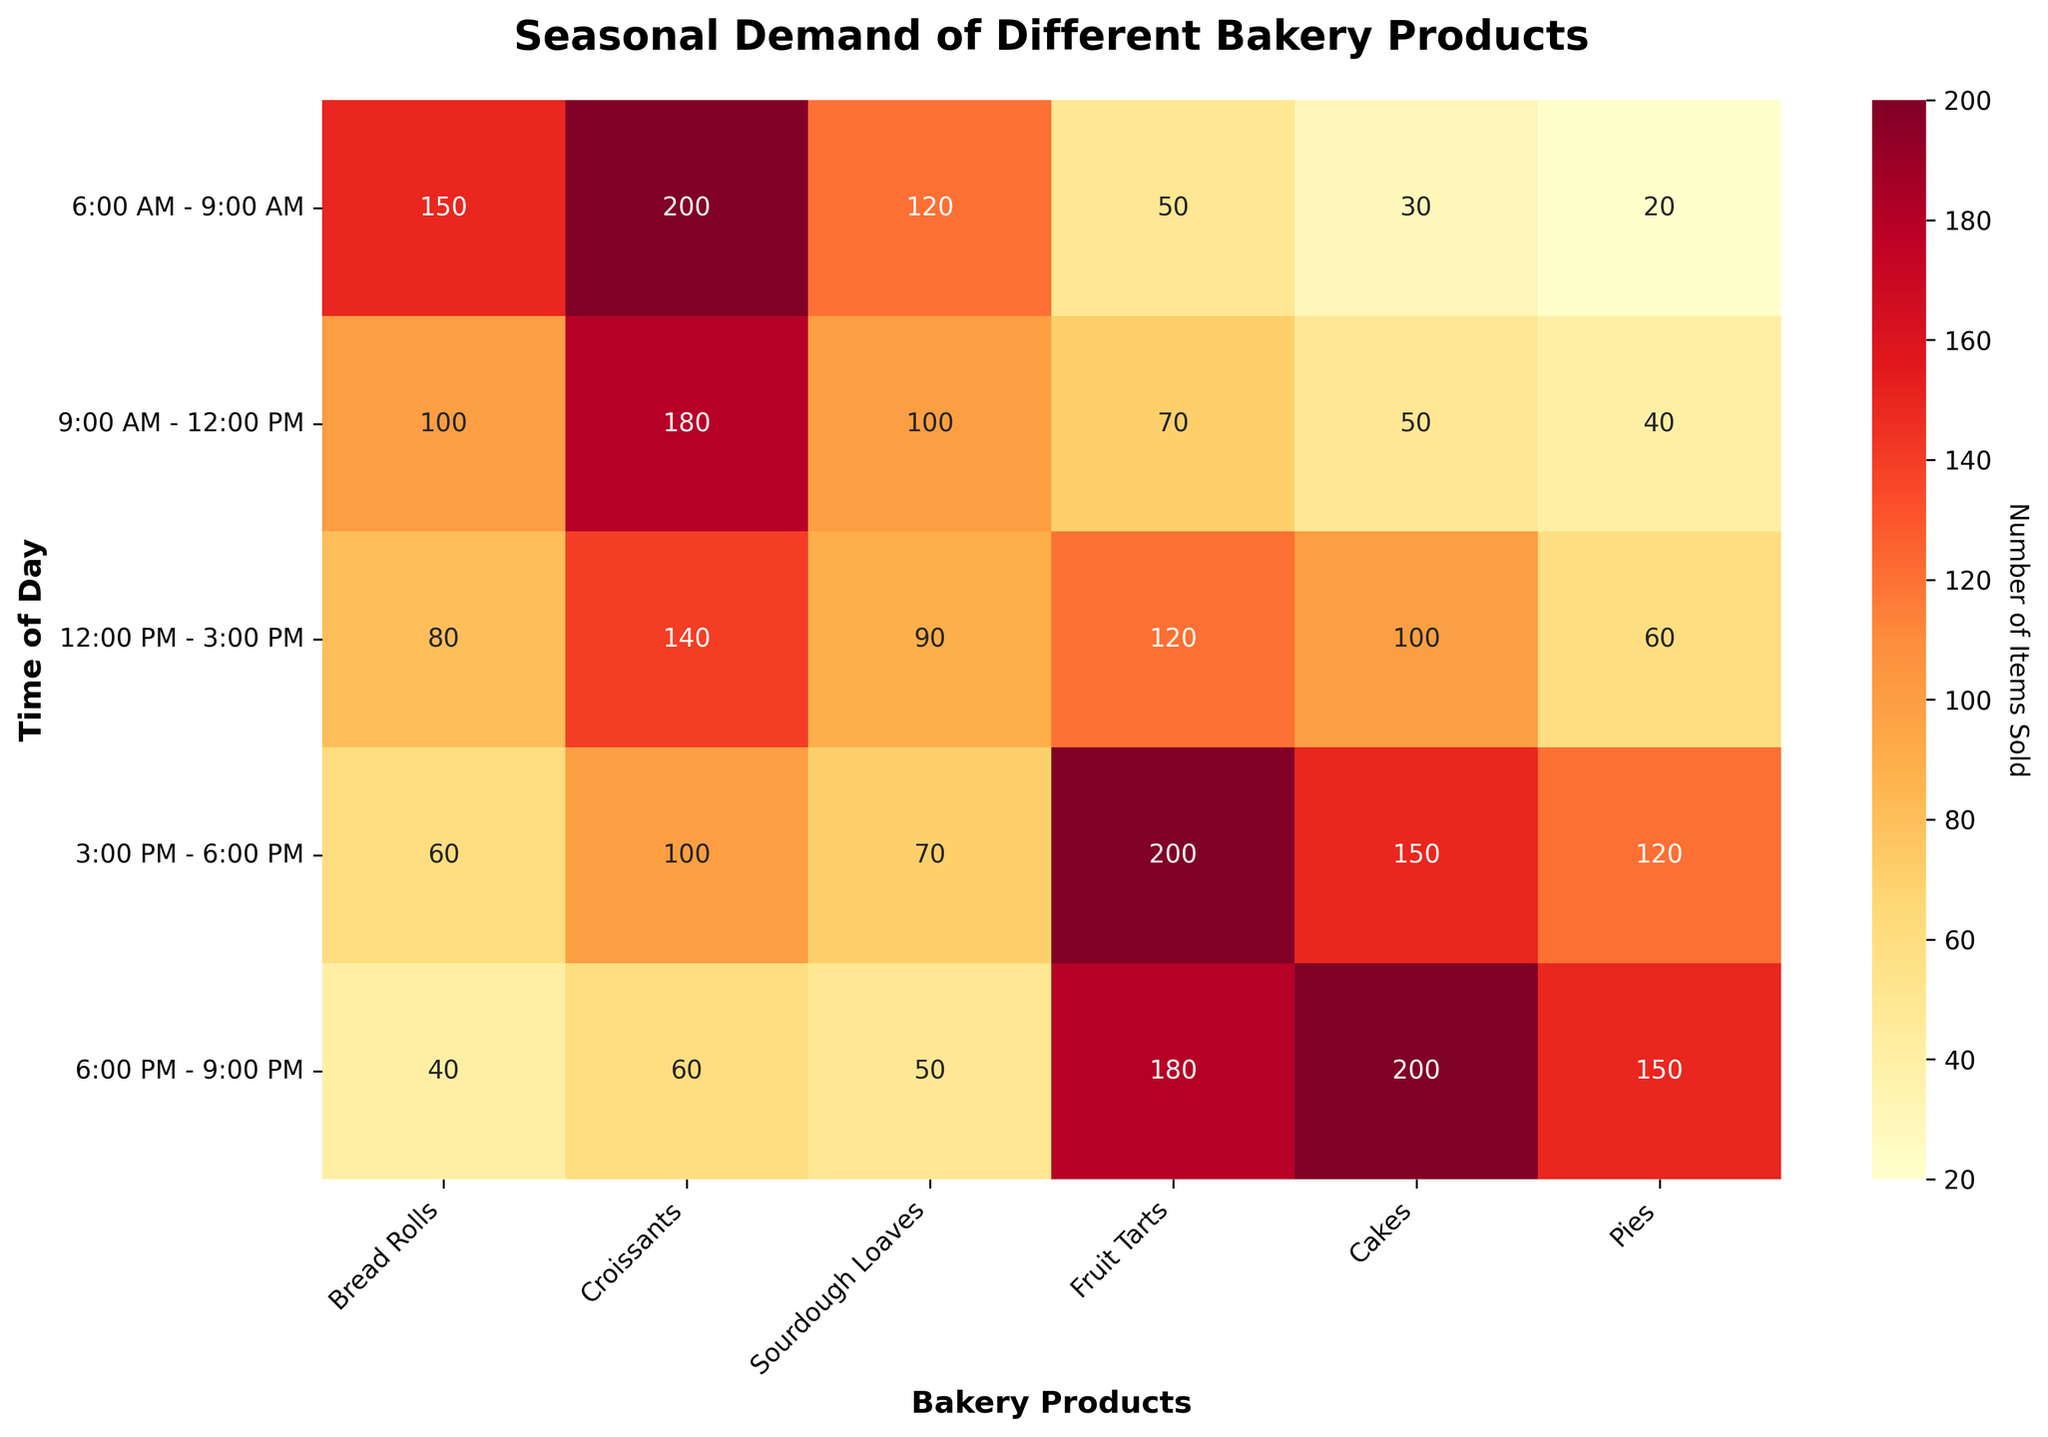What's the highest demand time for croissants? The highest demand time for croissants is found by locating the maximum value for the 'Croissants' column. The highest value in this column is 200 during the time slot 6:00 AM - 9:00 AM.
Answer: 6:00 AM - 9:00 AM Which bakery product has the highest demand during 3:00 PM - 6:00 PM? To find this, we need to look at the row corresponding to 3:00 PM - 6:00 PM and identify the highest value. The maximum value is 200 for Fruit Tarts.
Answer: Fruit Tarts How does the demand for bread rolls compare between the earliest and latest time slots? For this comparison, we look at the values for bread rolls at 6:00 AM - 9:00 AM and 6:00 PM - 9:00 PM. The values are 150 and 40, respectively, indicating a higher demand in the morning and a lower demand in the evening.
Answer: Higher in the morning, lower in the evening What is the average demand for cakes over all time slots? To find the average, sum the values for cakes across all time slots and divide by the number of time slots. The total demand is 30 + 50 + 100 + 150 + 200 = 530, and there are 5 time slots, so 530/5 = 106.
Answer: 106 During which time slot is the demand for pies equal to the demand for sourdough loaves? We need to compare the values in the Pies and Sourdough Loaves columns to find a match. The demand for pies and sourdough loaves is both 50 during the 6:00 PM - 9:00 PM time slot.
Answer: 6:00 PM - 9:00 PM What’s the total demand for all products at 9:00 AM - 12:00 PM? To find the total demand, sum all the values in the row for 9:00 AM - 12:00 PM. The totals are 100 (Bread Rolls) + 180 (Croissants) + 100 (Sourdough Loaves) + 70 (Fruit Tarts) + 50 (Cakes) + 40 (Pies) = 540.
Answer: 540 Is the demand for fruit tarts generally higher in the afternoon compared to the morning? We compare the demand for fruit tarts between the morning slots (6:00 AM - 12:00 PM) and the afternoon slots (12:00 PM - 6:00 PM). The morning demand is 50 + 70 = 120, and the afternoon demand is 120 + 200 = 320. The demand is higher in the afternoon.
Answer: Yes Which product has the least variation in demand throughout the day? To identify this, inspect the range of values (difference between the highest and lowest) for each product. Bread Rolls have values ranging from 40 to 150 (range = 110), Croissants from 60 to 200 (range = 140), Sourdough Loaves from 50 to 120 (range = 70), Fruit Tarts from 50 to 200 (range = 150), Cakes from 30 to 200 (range = 170), and Pies from 20 to 150 (range = 130). Sourdough Loaves have the least variation in demand (range = 70).
Answer: Sourdough Loaves 